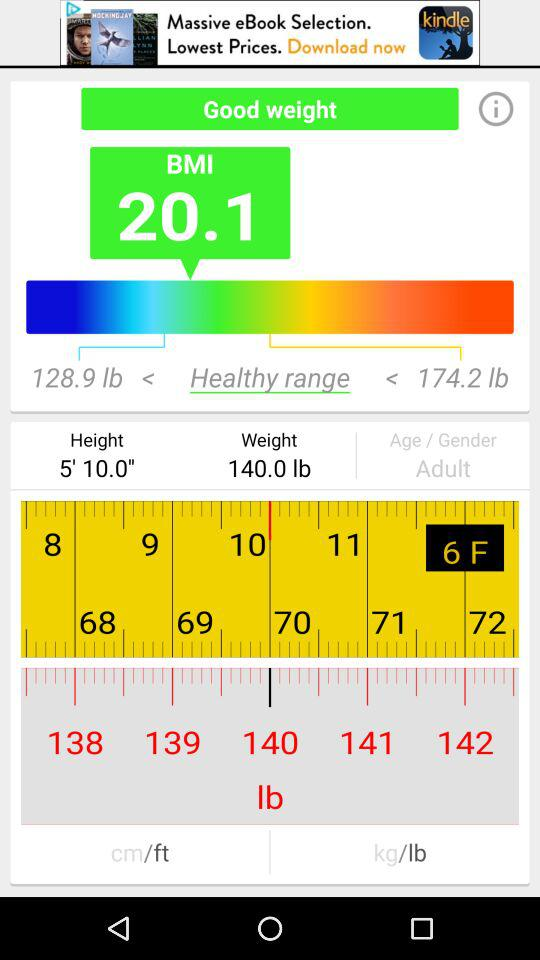What is the given weight? The given weight is 140.0 lb. 